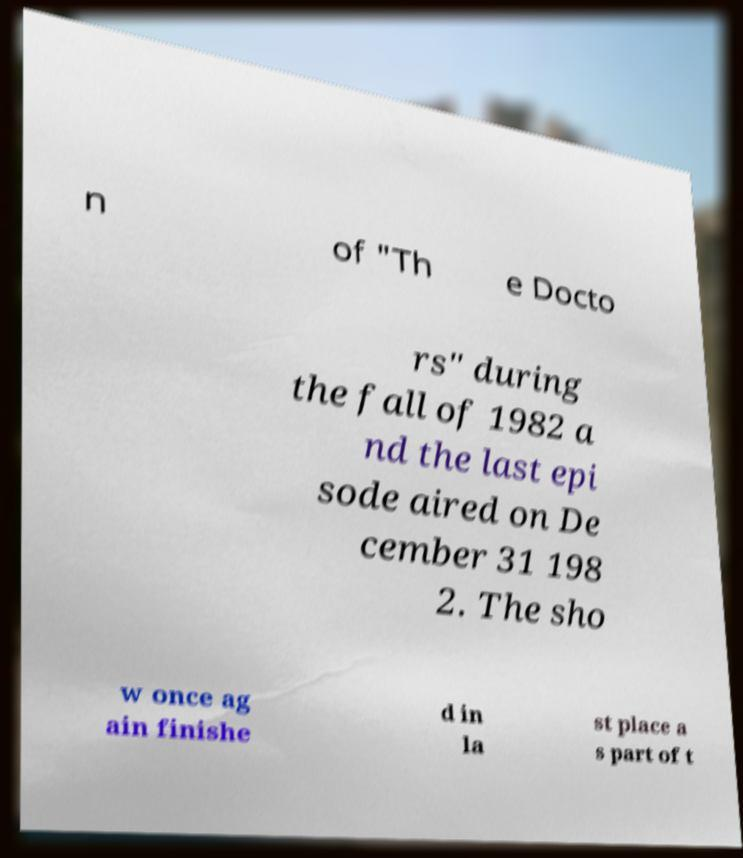What messages or text are displayed in this image? I need them in a readable, typed format. n of "Th e Docto rs" during the fall of 1982 a nd the last epi sode aired on De cember 31 198 2. The sho w once ag ain finishe d in la st place a s part of t 